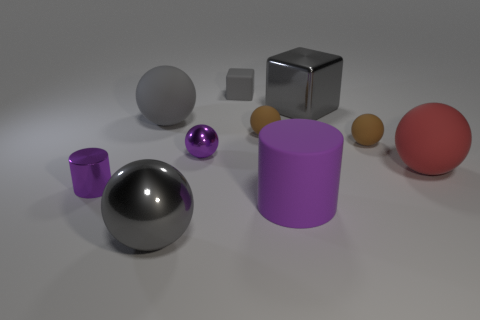Which objects in this image are reflective, and why might that be? The objects that show reflectiveness in the image are the large silver sphere, the smaller purple object, and the rightmost small sphere, which appears to be made of glass or polished stone. These objects might be reflective due to their material properties; metal, glass, and certain plastics have smooth surfaces that can reflect light, giving them a shiny appearance. 